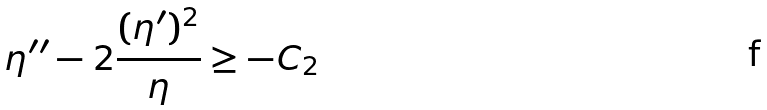<formula> <loc_0><loc_0><loc_500><loc_500>\eta ^ { \prime \prime } - 2 \frac { ( \eta ^ { \prime } ) ^ { 2 } } { \eta } \geq - C _ { 2 }</formula> 